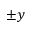Convert formula to latex. <formula><loc_0><loc_0><loc_500><loc_500>\pm y</formula> 